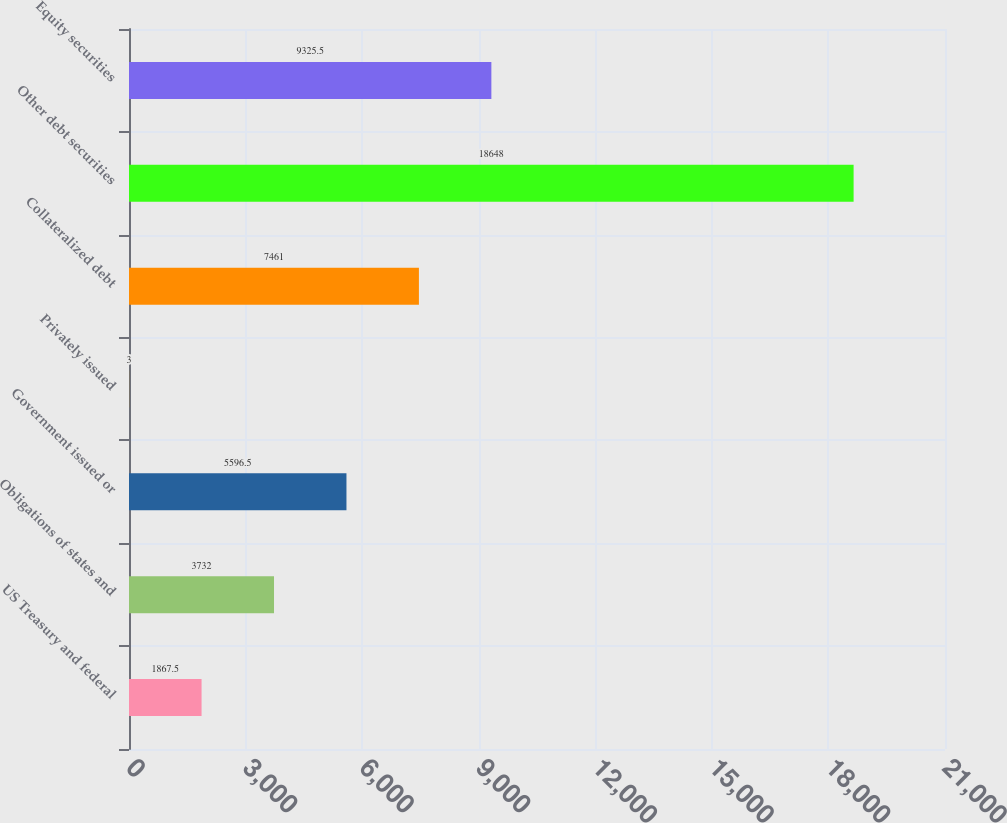<chart> <loc_0><loc_0><loc_500><loc_500><bar_chart><fcel>US Treasury and federal<fcel>Obligations of states and<fcel>Government issued or<fcel>Privately issued<fcel>Collateralized debt<fcel>Other debt securities<fcel>Equity securities<nl><fcel>1867.5<fcel>3732<fcel>5596.5<fcel>3<fcel>7461<fcel>18648<fcel>9325.5<nl></chart> 